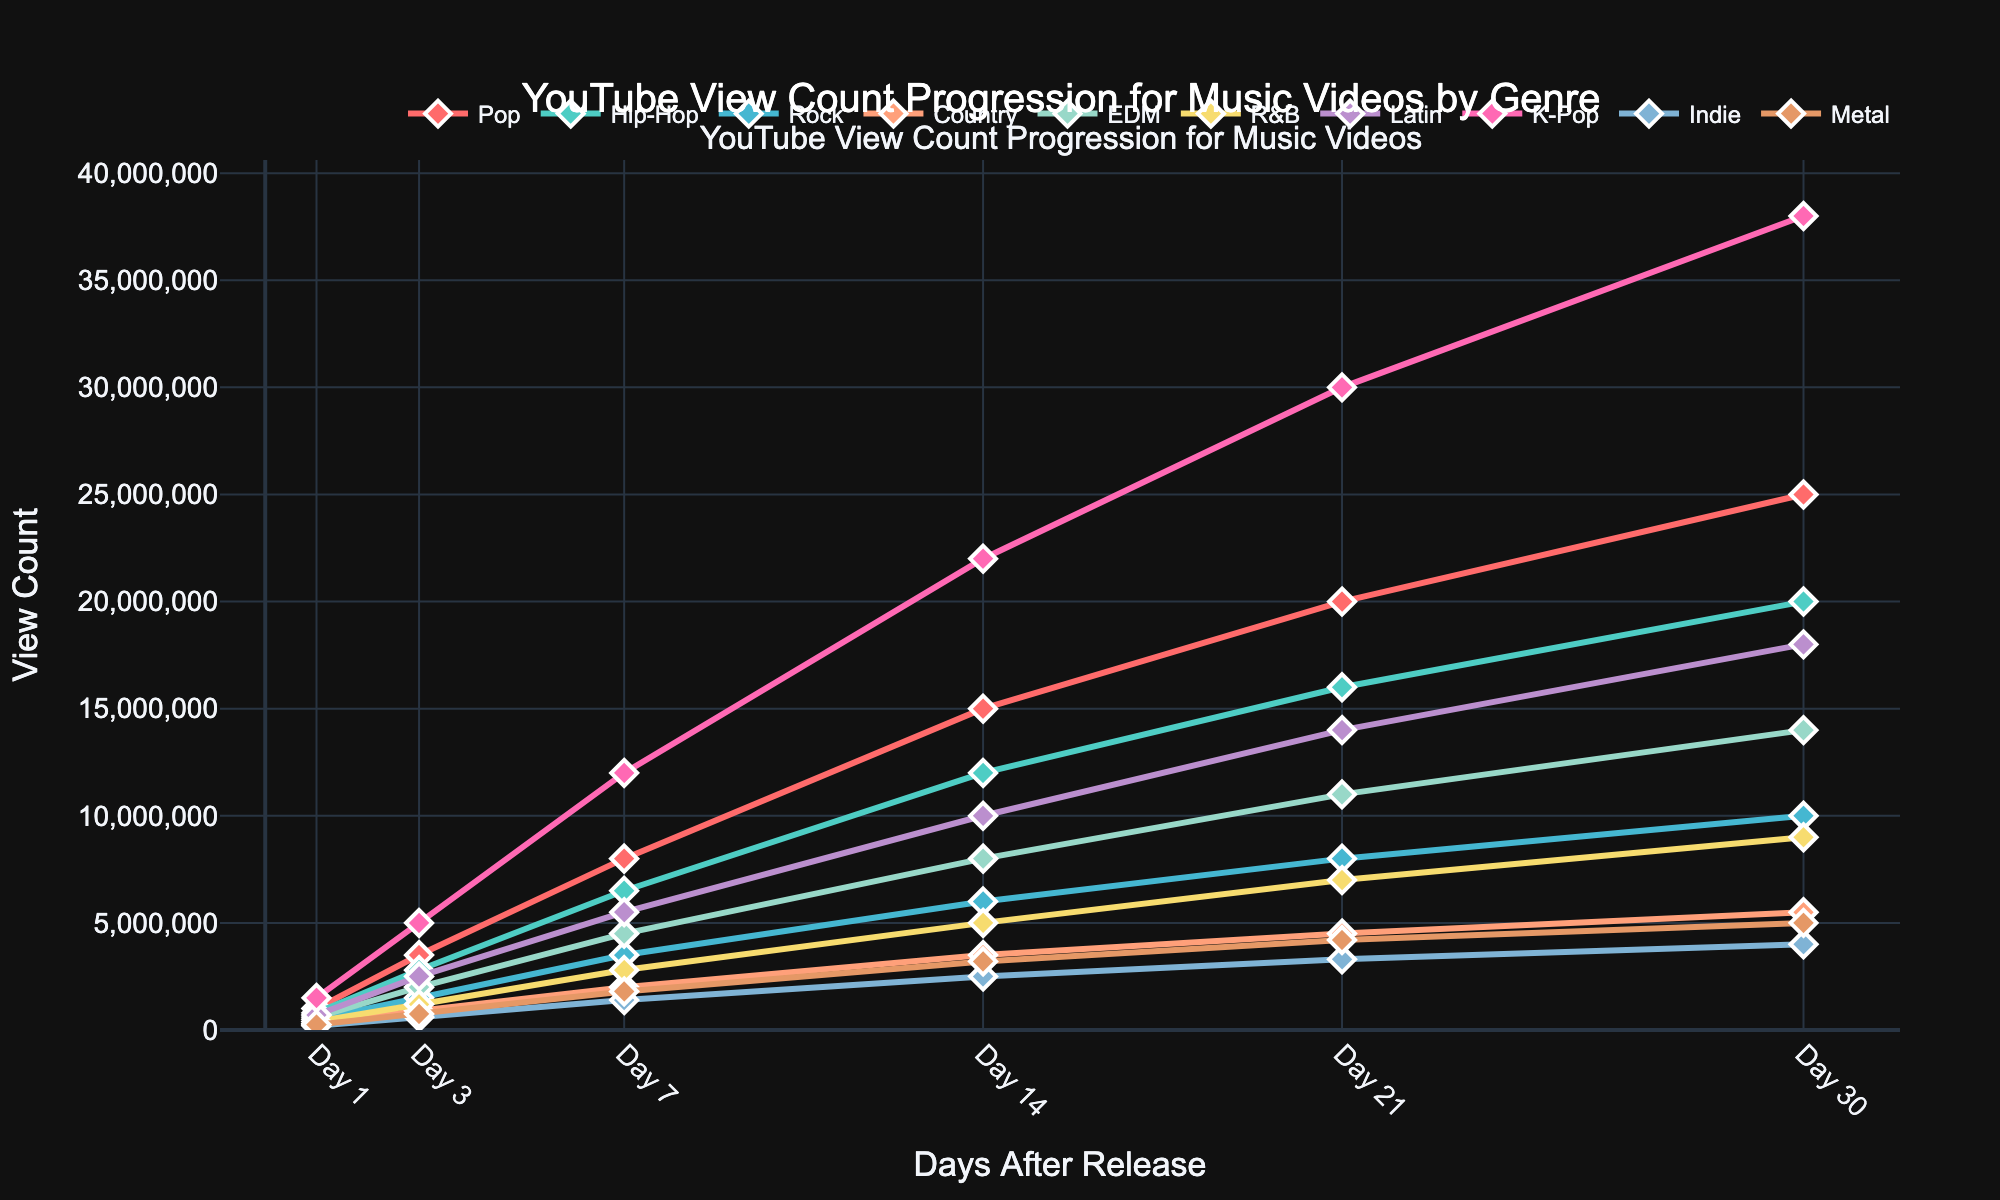Which genre had the highest view count on Day 7? The lines on the graph show that K-Pop had the highest view count on Day 7 with a value of 12,000,000.
Answer: K-Pop Which genres had a view count between 10,000,000 and 20,000,000 on Day 21? From the graph, we can see that Pop, Hip-Hop, EDM, Latin, and K-Pop fall within the range of 10,000,000 to 20,000,000 views on Day 21.
Answer: Pop, Hip-Hop, EDM, Latin What is the average view count across all genres on Day 14? To calculate the average view count on Day 14, add up all the values for Day 14 and divide by the number of genres: (15,000,000 + 12,000,000 + 6,000,000 + 3,500,000 + 8,000,000 + 5,000,000 + 10,000,000 + 22,000,000 + 2,500,000 + 3,200,000) / 10. The sum is 87,200,000, and dividing by 10 gives an average of 8,720,000.
Answer: 8,720,000 Which genre experienced the fastest growth in view count between Day 1 and Day 3? To find the genre with the fastest growth, subtract the Day 1 view count from the Day 3 view count for each genre and identify the largest difference. K-Pop had the biggest increase (5,000,000 - 1,500,000 = 3,500,000).
Answer: K-Pop Compare the view counts of Rock and EDM on Day 30, which genre has more views and by how much? The view count for Rock on Day 30 is 10,000,000 and for EDM it is 14,000,000. Subtract the Rock count from the EDM count to find the difference: 14,000,000 - 10,000,000 = 4,000,000.
Answer: EDM by 4,000,000 How does the view count of Country music on Day 30 compare with its count on Day 7? The view count for Country music on Day 30 is 5,500,000, and on Day 7 it is 2,000,000. The increase is 5,500,000 - 2,000,000 = 3,500,000.
Answer: Increased by 3,500,000 Which genre showed steady, uninterrupted growth in view count over the entire month? By visually inspecting the lines, we can see that Pop's view count increases steadily at each interval without any drops, indicating uninterrupted growth.
Answer: Pop What is the combined view count for Indie and Metal on Day 21? Add the view counts of Indie (3,300,000) and Metal (4,200,000) on Day 21: 3,300,000 + 4,200,000 = 7,500,000.
Answer: 7,500,000 On which day did Latin music surpass the 10,000,000 view count milestone? Observing the Latin line, it passes the 10,000,000 view count between Day 14 and Day 21, meaning it surpassed 10,000,000 on Day 14.
Answer: Day 14 